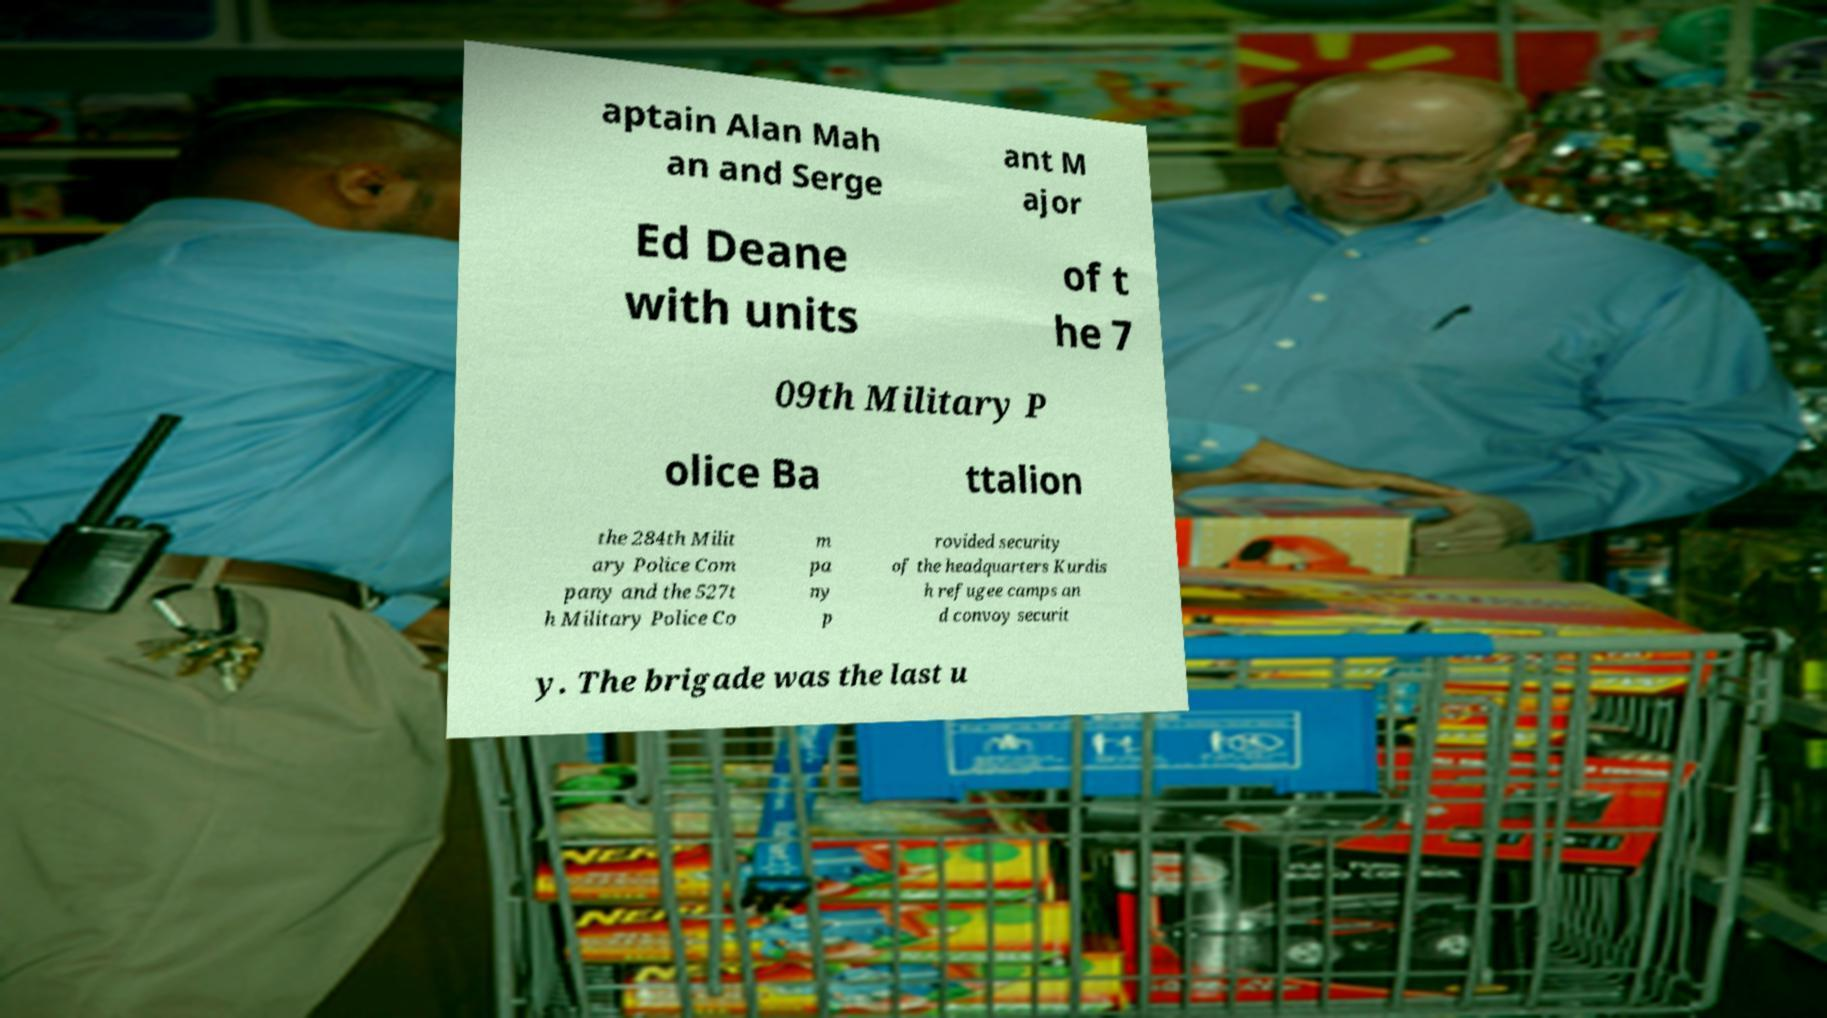Can you accurately transcribe the text from the provided image for me? aptain Alan Mah an and Serge ant M ajor Ed Deane with units of t he 7 09th Military P olice Ba ttalion the 284th Milit ary Police Com pany and the 527t h Military Police Co m pa ny p rovided security of the headquarters Kurdis h refugee camps an d convoy securit y. The brigade was the last u 